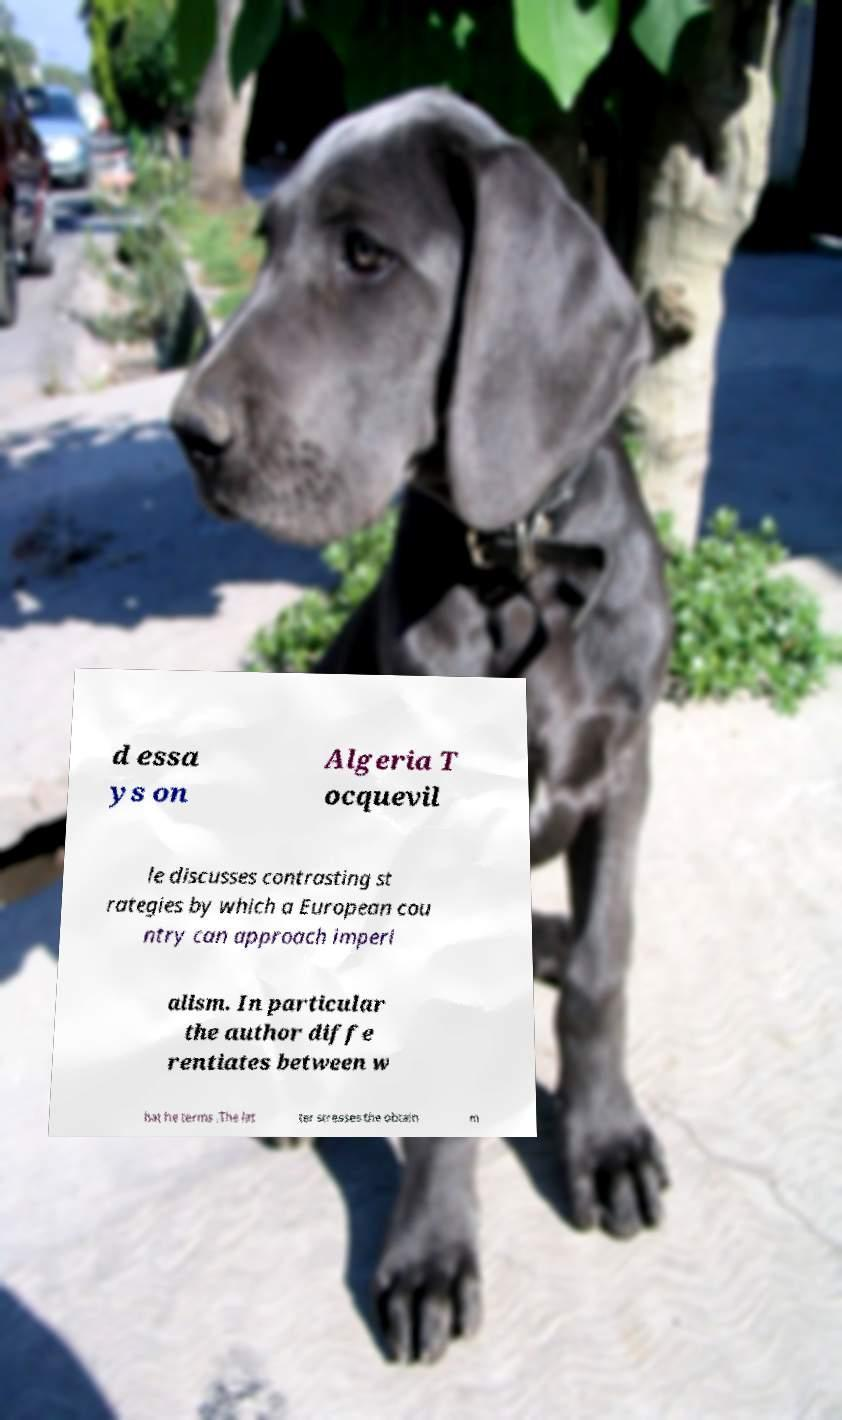Can you accurately transcribe the text from the provided image for me? d essa ys on Algeria T ocquevil le discusses contrasting st rategies by which a European cou ntry can approach imperi alism. In particular the author diffe rentiates between w hat he terms .The lat ter stresses the obtain m 